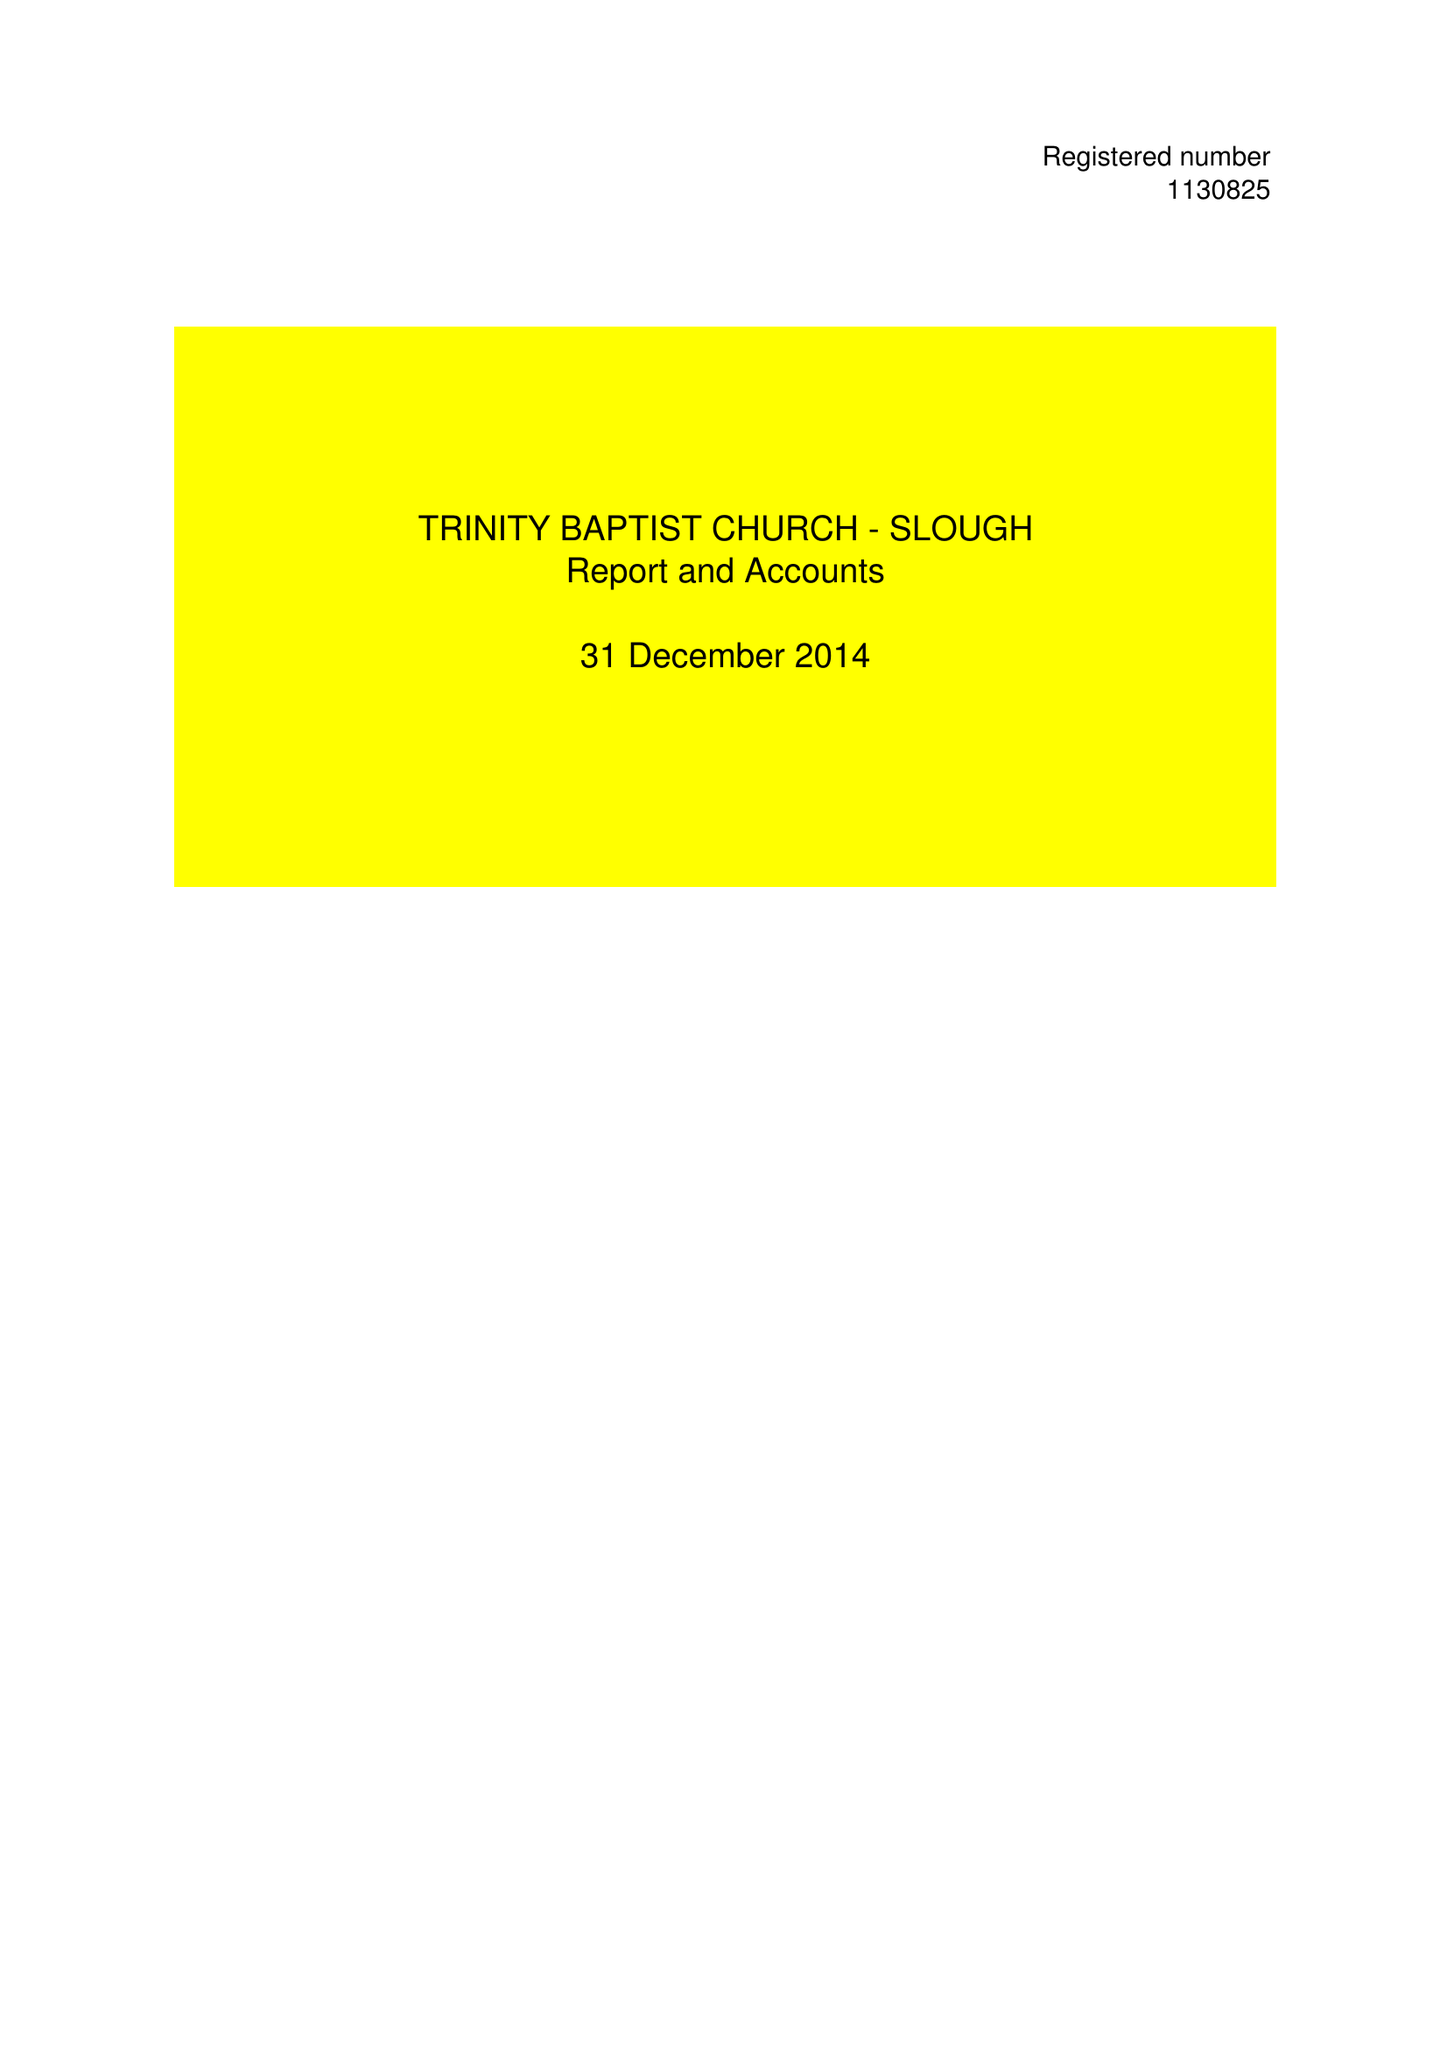What is the value for the address__post_town?
Answer the question using a single word or phrase. MITCHAM 